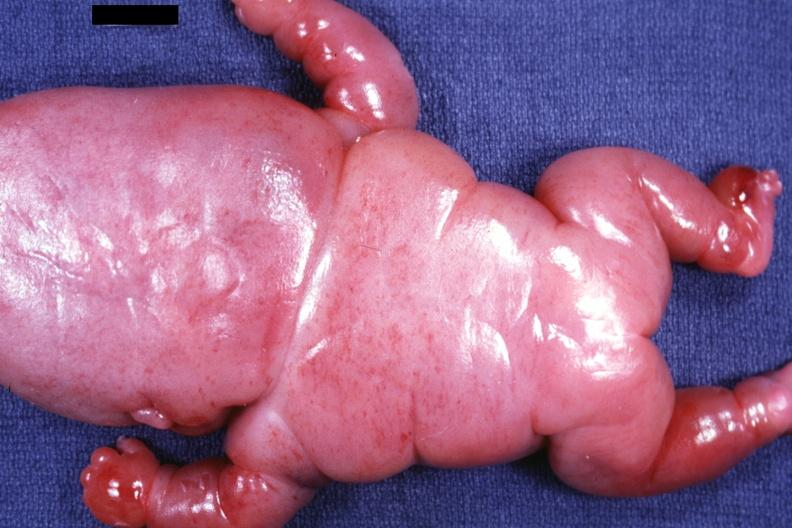does mesothelioma show posterior view of body lesions mostly in head neck and thorax?
Answer the question using a single word or phrase. No 